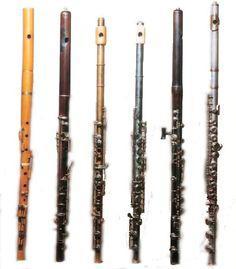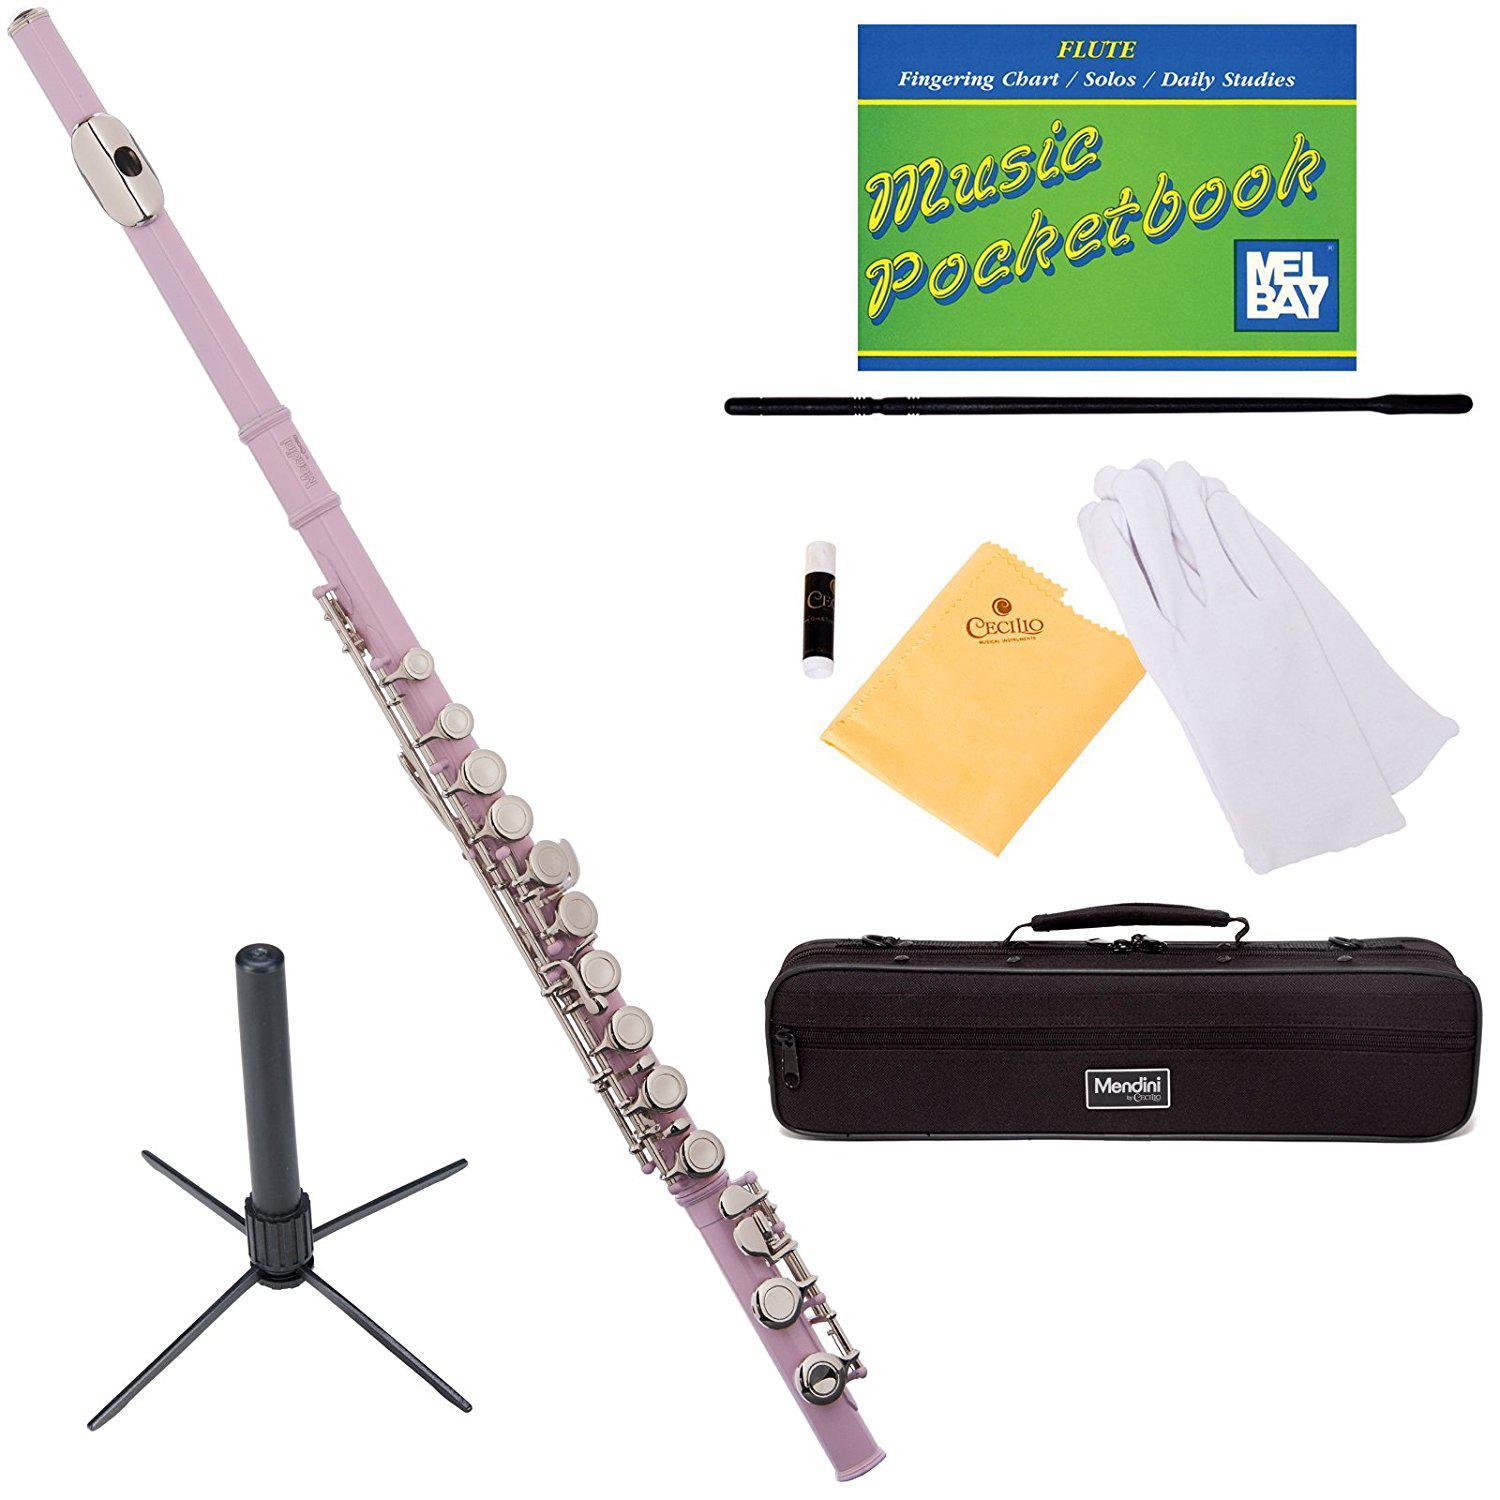The first image is the image on the left, the second image is the image on the right. Assess this claim about the two images: "The background of one of the images is blue.". Correct or not? Answer yes or no. No. The first image is the image on the left, the second image is the image on the right. Considering the images on both sides, is "One image contains exactly four wooden flutes displayed in a row, with cords at their tops." valid? Answer yes or no. No. 